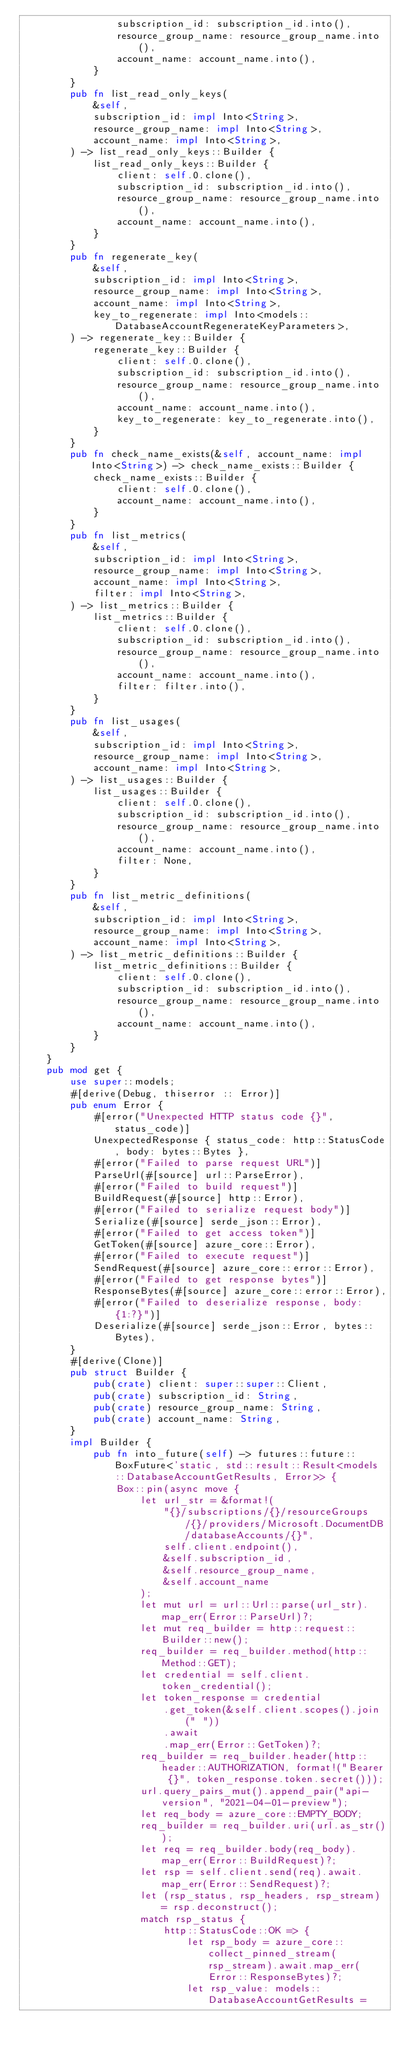Convert code to text. <code><loc_0><loc_0><loc_500><loc_500><_Rust_>                subscription_id: subscription_id.into(),
                resource_group_name: resource_group_name.into(),
                account_name: account_name.into(),
            }
        }
        pub fn list_read_only_keys(
            &self,
            subscription_id: impl Into<String>,
            resource_group_name: impl Into<String>,
            account_name: impl Into<String>,
        ) -> list_read_only_keys::Builder {
            list_read_only_keys::Builder {
                client: self.0.clone(),
                subscription_id: subscription_id.into(),
                resource_group_name: resource_group_name.into(),
                account_name: account_name.into(),
            }
        }
        pub fn regenerate_key(
            &self,
            subscription_id: impl Into<String>,
            resource_group_name: impl Into<String>,
            account_name: impl Into<String>,
            key_to_regenerate: impl Into<models::DatabaseAccountRegenerateKeyParameters>,
        ) -> regenerate_key::Builder {
            regenerate_key::Builder {
                client: self.0.clone(),
                subscription_id: subscription_id.into(),
                resource_group_name: resource_group_name.into(),
                account_name: account_name.into(),
                key_to_regenerate: key_to_regenerate.into(),
            }
        }
        pub fn check_name_exists(&self, account_name: impl Into<String>) -> check_name_exists::Builder {
            check_name_exists::Builder {
                client: self.0.clone(),
                account_name: account_name.into(),
            }
        }
        pub fn list_metrics(
            &self,
            subscription_id: impl Into<String>,
            resource_group_name: impl Into<String>,
            account_name: impl Into<String>,
            filter: impl Into<String>,
        ) -> list_metrics::Builder {
            list_metrics::Builder {
                client: self.0.clone(),
                subscription_id: subscription_id.into(),
                resource_group_name: resource_group_name.into(),
                account_name: account_name.into(),
                filter: filter.into(),
            }
        }
        pub fn list_usages(
            &self,
            subscription_id: impl Into<String>,
            resource_group_name: impl Into<String>,
            account_name: impl Into<String>,
        ) -> list_usages::Builder {
            list_usages::Builder {
                client: self.0.clone(),
                subscription_id: subscription_id.into(),
                resource_group_name: resource_group_name.into(),
                account_name: account_name.into(),
                filter: None,
            }
        }
        pub fn list_metric_definitions(
            &self,
            subscription_id: impl Into<String>,
            resource_group_name: impl Into<String>,
            account_name: impl Into<String>,
        ) -> list_metric_definitions::Builder {
            list_metric_definitions::Builder {
                client: self.0.clone(),
                subscription_id: subscription_id.into(),
                resource_group_name: resource_group_name.into(),
                account_name: account_name.into(),
            }
        }
    }
    pub mod get {
        use super::models;
        #[derive(Debug, thiserror :: Error)]
        pub enum Error {
            #[error("Unexpected HTTP status code {}", status_code)]
            UnexpectedResponse { status_code: http::StatusCode, body: bytes::Bytes },
            #[error("Failed to parse request URL")]
            ParseUrl(#[source] url::ParseError),
            #[error("Failed to build request")]
            BuildRequest(#[source] http::Error),
            #[error("Failed to serialize request body")]
            Serialize(#[source] serde_json::Error),
            #[error("Failed to get access token")]
            GetToken(#[source] azure_core::Error),
            #[error("Failed to execute request")]
            SendRequest(#[source] azure_core::error::Error),
            #[error("Failed to get response bytes")]
            ResponseBytes(#[source] azure_core::error::Error),
            #[error("Failed to deserialize response, body: {1:?}")]
            Deserialize(#[source] serde_json::Error, bytes::Bytes),
        }
        #[derive(Clone)]
        pub struct Builder {
            pub(crate) client: super::super::Client,
            pub(crate) subscription_id: String,
            pub(crate) resource_group_name: String,
            pub(crate) account_name: String,
        }
        impl Builder {
            pub fn into_future(self) -> futures::future::BoxFuture<'static, std::result::Result<models::DatabaseAccountGetResults, Error>> {
                Box::pin(async move {
                    let url_str = &format!(
                        "{}/subscriptions/{}/resourceGroups/{}/providers/Microsoft.DocumentDB/databaseAccounts/{}",
                        self.client.endpoint(),
                        &self.subscription_id,
                        &self.resource_group_name,
                        &self.account_name
                    );
                    let mut url = url::Url::parse(url_str).map_err(Error::ParseUrl)?;
                    let mut req_builder = http::request::Builder::new();
                    req_builder = req_builder.method(http::Method::GET);
                    let credential = self.client.token_credential();
                    let token_response = credential
                        .get_token(&self.client.scopes().join(" "))
                        .await
                        .map_err(Error::GetToken)?;
                    req_builder = req_builder.header(http::header::AUTHORIZATION, format!("Bearer {}", token_response.token.secret()));
                    url.query_pairs_mut().append_pair("api-version", "2021-04-01-preview");
                    let req_body = azure_core::EMPTY_BODY;
                    req_builder = req_builder.uri(url.as_str());
                    let req = req_builder.body(req_body).map_err(Error::BuildRequest)?;
                    let rsp = self.client.send(req).await.map_err(Error::SendRequest)?;
                    let (rsp_status, rsp_headers, rsp_stream) = rsp.deconstruct();
                    match rsp_status {
                        http::StatusCode::OK => {
                            let rsp_body = azure_core::collect_pinned_stream(rsp_stream).await.map_err(Error::ResponseBytes)?;
                            let rsp_value: models::DatabaseAccountGetResults =</code> 